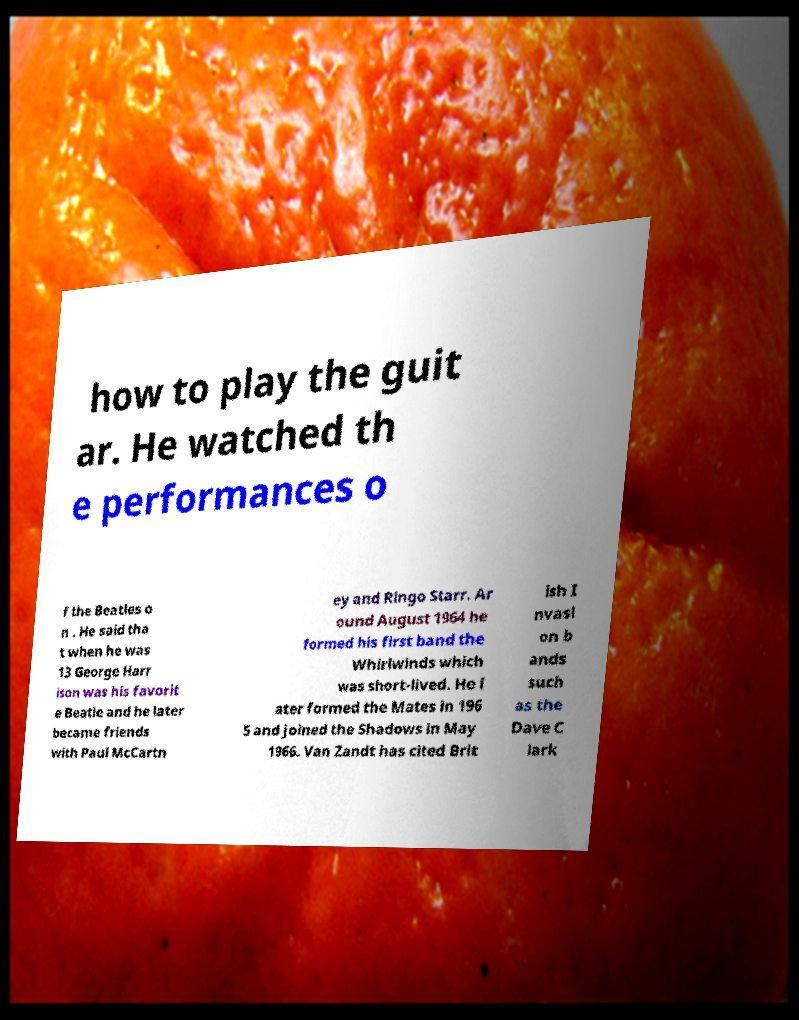Could you extract and type out the text from this image? how to play the guit ar. He watched th e performances o f the Beatles o n . He said tha t when he was 13 George Harr ison was his favorit e Beatle and he later became friends with Paul McCartn ey and Ringo Starr. Ar ound August 1964 he formed his first band the Whirlwinds which was short-lived. He l ater formed the Mates in 196 5 and joined the Shadows in May 1966. Van Zandt has cited Brit ish I nvasi on b ands such as the Dave C lark 